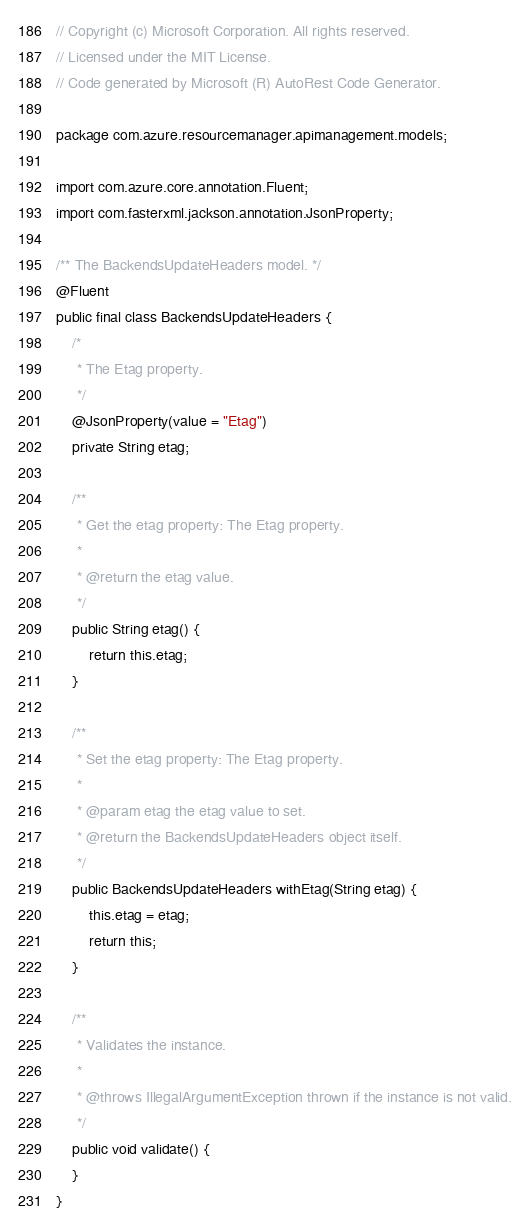Convert code to text. <code><loc_0><loc_0><loc_500><loc_500><_Java_>// Copyright (c) Microsoft Corporation. All rights reserved.
// Licensed under the MIT License.
// Code generated by Microsoft (R) AutoRest Code Generator.

package com.azure.resourcemanager.apimanagement.models;

import com.azure.core.annotation.Fluent;
import com.fasterxml.jackson.annotation.JsonProperty;

/** The BackendsUpdateHeaders model. */
@Fluent
public final class BackendsUpdateHeaders {
    /*
     * The Etag property.
     */
    @JsonProperty(value = "Etag")
    private String etag;

    /**
     * Get the etag property: The Etag property.
     *
     * @return the etag value.
     */
    public String etag() {
        return this.etag;
    }

    /**
     * Set the etag property: The Etag property.
     *
     * @param etag the etag value to set.
     * @return the BackendsUpdateHeaders object itself.
     */
    public BackendsUpdateHeaders withEtag(String etag) {
        this.etag = etag;
        return this;
    }

    /**
     * Validates the instance.
     *
     * @throws IllegalArgumentException thrown if the instance is not valid.
     */
    public void validate() {
    }
}
</code> 